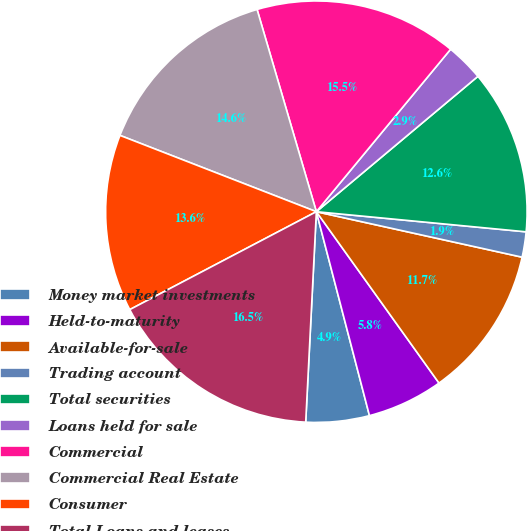Convert chart. <chart><loc_0><loc_0><loc_500><loc_500><pie_chart><fcel>Money market investments<fcel>Held-to-maturity<fcel>Available-for-sale<fcel>Trading account<fcel>Total securities<fcel>Loans held for sale<fcel>Commercial<fcel>Commercial Real Estate<fcel>Consumer<fcel>Total Loans and leases<nl><fcel>4.86%<fcel>5.83%<fcel>11.65%<fcel>1.94%<fcel>12.62%<fcel>2.91%<fcel>15.53%<fcel>14.56%<fcel>13.59%<fcel>16.5%<nl></chart> 